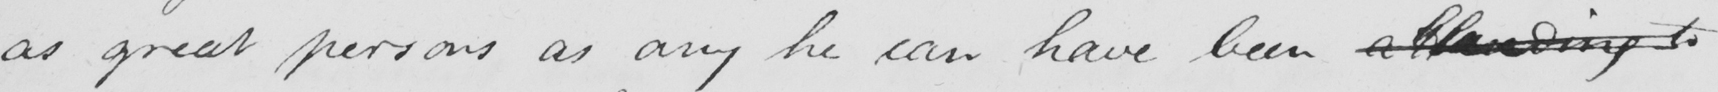What is written in this line of handwriting? as great persons as any he can have been attending to 